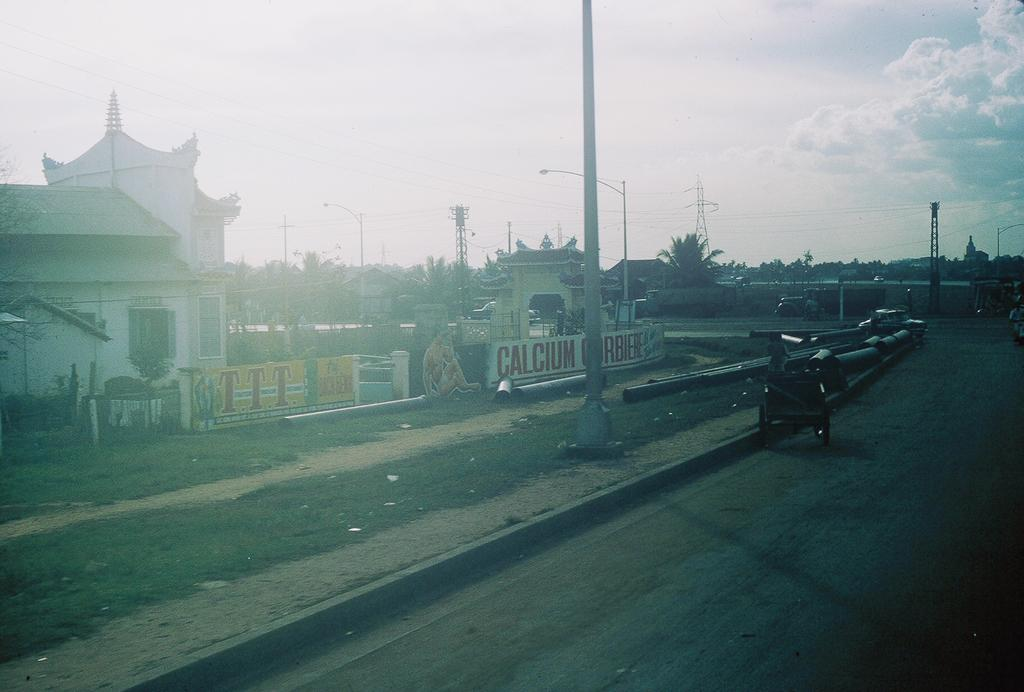What type of structures can be seen in the image? There are houses, poles, towers, and walls visible in the image. What type of vegetation is present in the image? There are trees and grass visible in the image. What is located at the bottom of the image? There is a road at the bottom of the image. What is moving along the road in the image? There are vehicles on the road. What can be seen in the background of the image? The sky is visible in the background of the image. What does the son of the carpenter hate in the image? There is no son of a carpenter or any indication of hate in the image. 